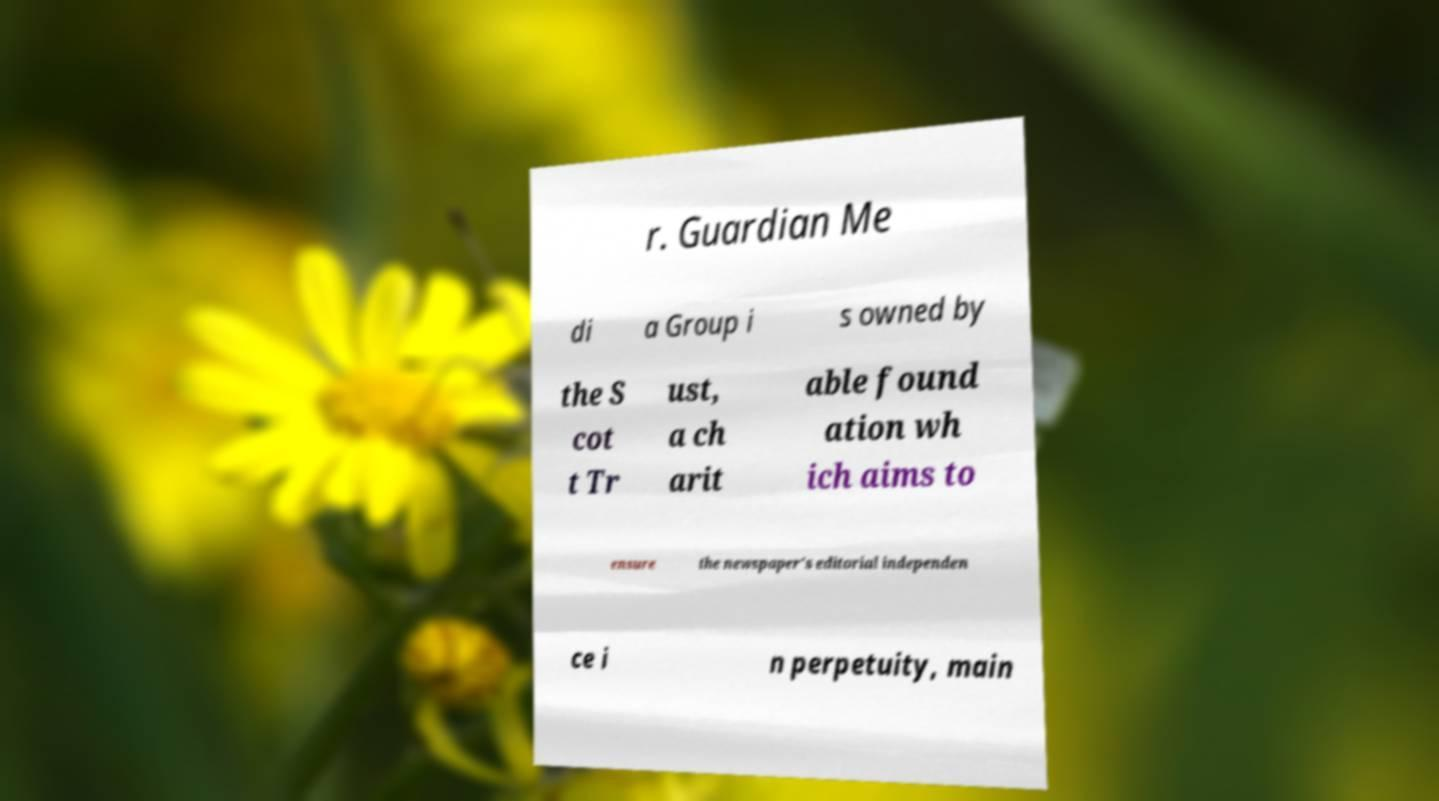Could you assist in decoding the text presented in this image and type it out clearly? r. Guardian Me di a Group i s owned by the S cot t Tr ust, a ch arit able found ation wh ich aims to ensure the newspaper's editorial independen ce i n perpetuity, main 